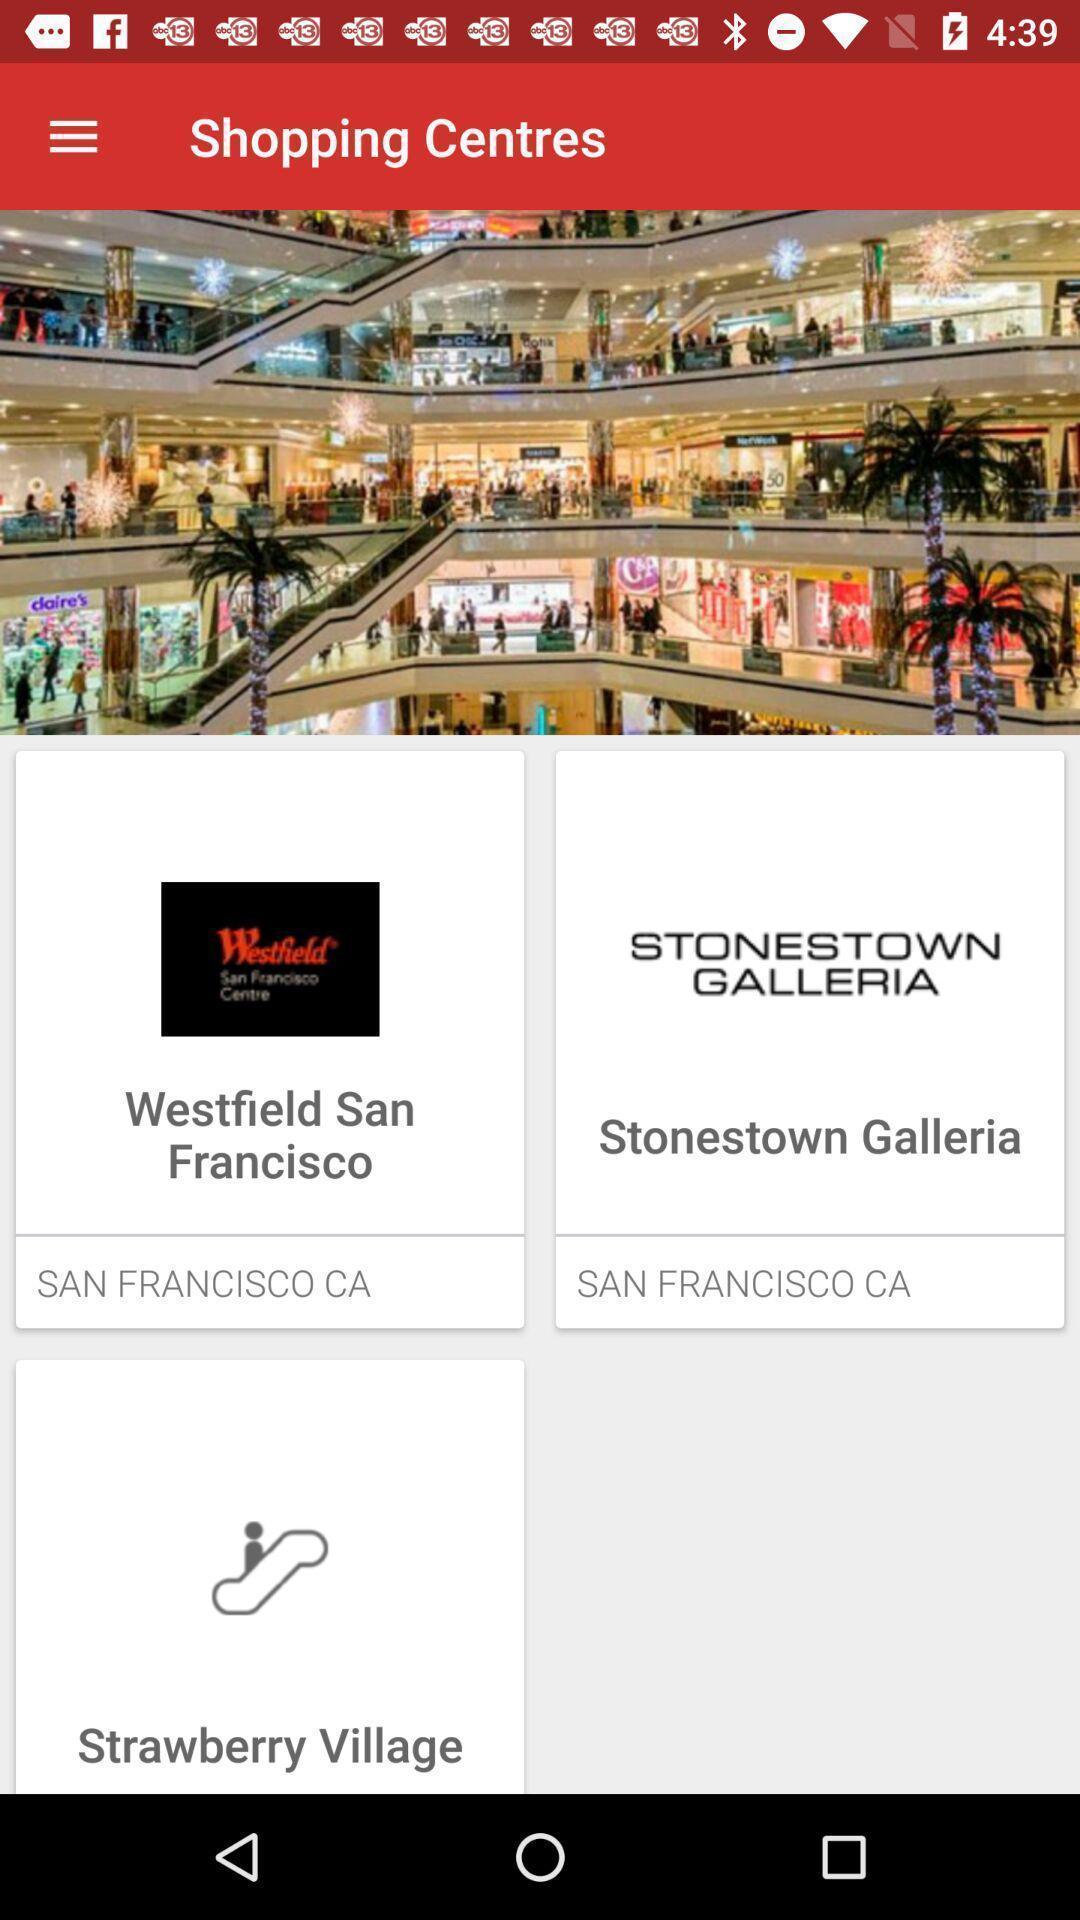Give me a narrative description of this picture. Screen displaying the image of a shopping complex. 